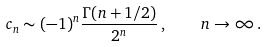<formula> <loc_0><loc_0><loc_500><loc_500>c _ { n } \sim ( - 1 ) ^ { n } \frac { \Gamma ( n + 1 / 2 ) } { 2 ^ { n } } \, , \quad n \to \infty \, .</formula> 